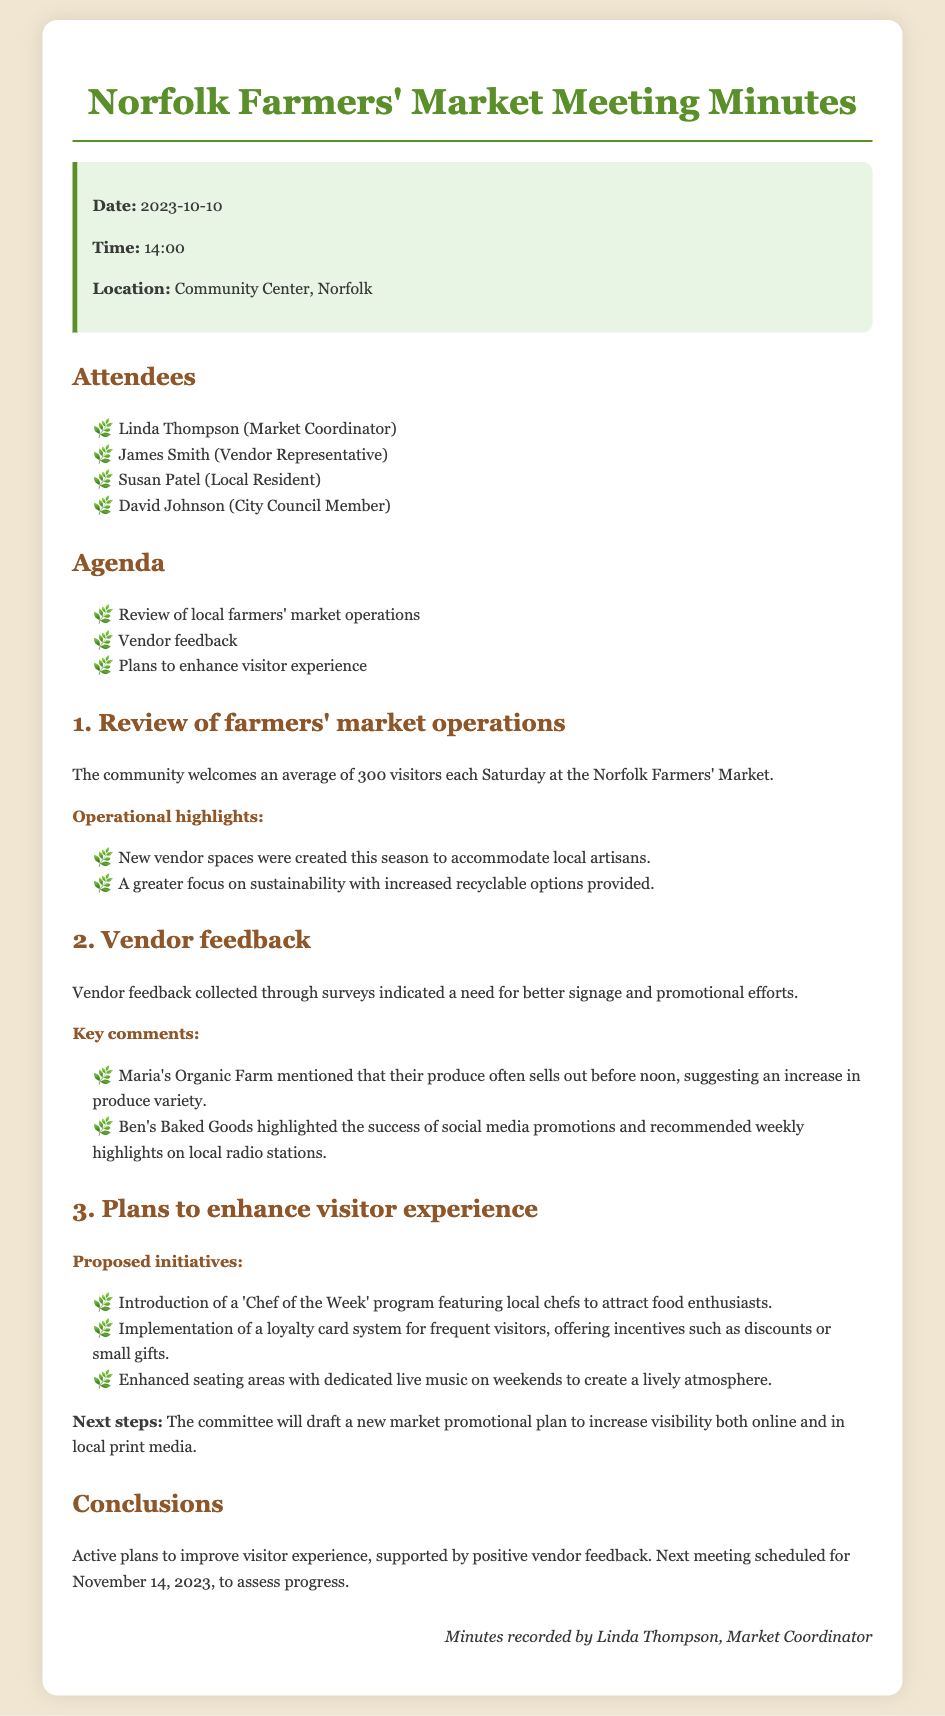What is the date of the meeting? The date of the meeting is mentioned at the beginning of the document.
Answer: 2023-10-10 How many visitors does the market welcome each Saturday? The document states the average number of visitors welcomed each Saturday at the market.
Answer: 300 What vendor suggestion was made regarding produce variety? The document notes a specific comment from a vendor about producing selling out and suggests an increase.
Answer: Increase in produce variety What is the 'Chef of the Week' program? The document describes a proposed initiative aimed at enhancing the visitor experience through featuring local chefs.
Answer: Featuring local chefs What is the next meeting date? The last part of the document specifies when the next meeting is scheduled.
Answer: November 14, 2023 Which market feature was highlighted for sustainability? The document mentions one operational highlight focused on sustainability.
Answer: Increased recyclable options What promotional strategy was mentioned by Ben's Baked Goods? The document includes the success and recommendation brought up by a vendor regarding promotions.
Answer: Weekly highlights on local radio stations Who recorded the minutes? The document contains the name of the person who recorded the meeting minutes at the end of the document.
Answer: Linda Thompson 